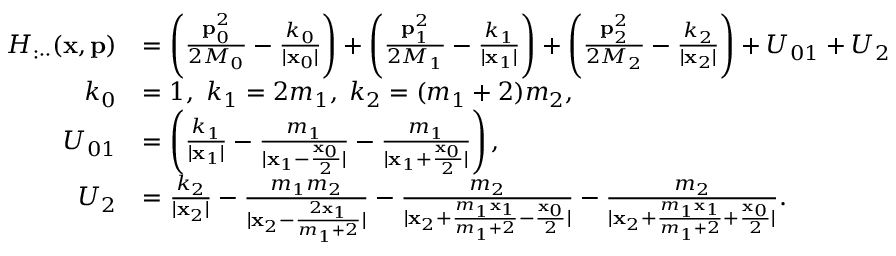Convert formula to latex. <formula><loc_0><loc_0><loc_500><loc_500>\begin{array} { r l } { H _ { \colon \cdot \cdot } ( x , p ) } & { = \left ( \frac { p _ { 0 } ^ { 2 } } { 2 M _ { 0 } } - \frac { k _ { 0 } } { | x _ { 0 } | } \right ) + \left ( \frac { p _ { 1 } ^ { 2 } } { 2 M _ { 1 } } - \frac { k _ { 1 } } { | x _ { 1 } | } \right ) + \left ( \frac { p _ { 2 } ^ { 2 } } { 2 M _ { 2 } } - \frac { k _ { 2 } } { | x _ { 2 } | } \right ) + U _ { 0 1 } + U _ { 2 } } \\ { k _ { 0 } } & { = 1 , \ k _ { 1 } = 2 m _ { 1 } , \, k _ { 2 } = ( m _ { 1 } + 2 ) m _ { 2 } , } \\ { U _ { 0 1 } } & { = \left ( \frac { k _ { 1 } } { | x _ { 1 } | } - \frac { m _ { 1 } } { | x _ { 1 } - \frac { x _ { 0 } } { 2 } | } - \frac { m _ { 1 } } { | x _ { 1 } + \frac { x _ { 0 } } { 2 } | } \right ) , } \\ { U _ { 2 } } & { = \frac { k _ { 2 } } { | x _ { 2 } | } - \frac { m _ { 1 } m _ { 2 } } { | x _ { 2 } - \frac { 2 x _ { 1 } } { m _ { 1 } + 2 } | } - \frac { m _ { 2 } } { | x _ { 2 } + \frac { m _ { 1 } x _ { 1 } } { m _ { 1 } + 2 } - \frac { x _ { 0 } } { 2 } | } - \frac { m _ { 2 } } { | x _ { 2 } + \frac { m _ { 1 } x _ { 1 } } { m _ { 1 } + 2 } + \frac { x _ { 0 } } { 2 } | } . } \end{array}</formula> 